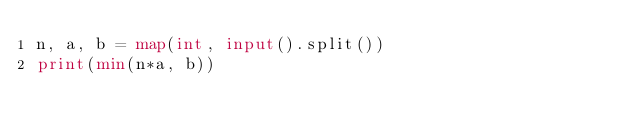Convert code to text. <code><loc_0><loc_0><loc_500><loc_500><_Python_>n, a, b = map(int, input().split())
print(min(n*a, b))</code> 